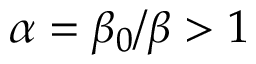<formula> <loc_0><loc_0><loc_500><loc_500>\alpha = \beta _ { 0 } / \beta > 1</formula> 